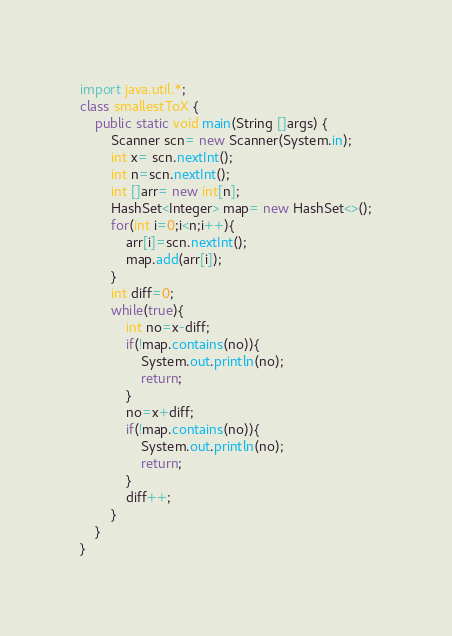Convert code to text. <code><loc_0><loc_0><loc_500><loc_500><_Java_>import java.util.*;
class smallestToX {
    public static void main(String []args) {
        Scanner scn= new Scanner(System.in);
        int x= scn.nextInt();
        int n=scn.nextInt();
        int []arr= new int[n];
        HashSet<Integer> map= new HashSet<>();
        for(int i=0;i<n;i++){
            arr[i]=scn.nextInt();
            map.add(arr[i]);
        }
        int diff=0;
        while(true){
            int no=x-diff;
            if(!map.contains(no)){
                System.out.println(no);
                return;
            }
            no=x+diff;
            if(!map.contains(no)){
                System.out.println(no);
                return;
            }
            diff++;
        }
    }
}</code> 